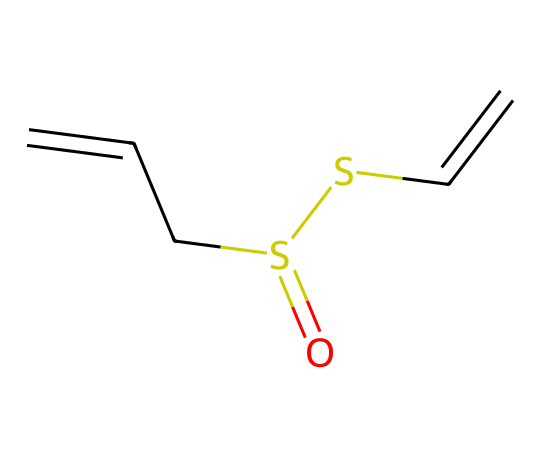What is the molecular formula of allicin? The SMILES representation indicates the atoms present: there are 6 carbon (C), 10 hydrogen (H), 2 sulfur (S), and 2 oxygen (O) atoms. Therefore, the molecular formula can be derived as C6H10O2S2.
Answer: C6H10O2S2 How many sulfur atoms are in this compound? By inspecting the SMILES string, we can count the "S" letters present in the representation. There are two "S" letters, indicating two sulfur atoms are present.
Answer: 2 What type of chemical bonding is present between the carbon atoms? The structure shows a mix of double bonds (noted by the "=" symbol) and single bonds connecting the carbon atoms. Double bonds characterize alkenes, while single bonds are typical of alkanes.
Answer: double and single bonds What functional groups can be identified in allicin? Analyzing the structure, we can observe that allicin contains a thioether (the -S- group between two carbon chains) and a sulfoxide (due to the sulfur double-bonded to oxygen), which are both functional groups present in the molecule.
Answer: thioether and sulfoxide Is allicin classified as a thiol or a thioether? The presence of the sulfur atoms bonded to carbon chains and the lack of an -SH (thiol) group indicates that allicin is classified as a thioether, as it involves sulfurs bonded between carbon atoms without a terminal hydrogen.
Answer: thioether How many total bonds are represented in the allicin structure? Each bond in the SMILES can be counted: single and double bonds are counted where each double bond is equivalent to 2 single bonds. Counting them gives a total of 9 bonds present in the structure.
Answer: 9 